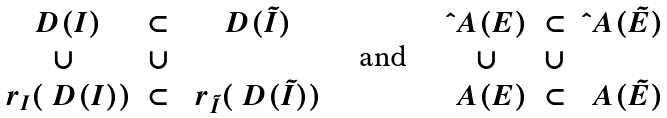Convert formula to latex. <formula><loc_0><loc_0><loc_500><loc_500>\begin{matrix} \ D ( I ) & \subset & \ D ( \tilde { I } ) \\ \cup & \cup \\ \ r _ { I } ( \ D ( I ) ) & \subset & \ r _ { \tilde { I } } ( \ D ( \tilde { I } ) ) \end{matrix} \ \quad \text {and} \ \quad \begin{matrix} \hat { \ } A ( E ) & \subset & \hat { \ } A ( \tilde { E } ) \\ \cup & \cup \\ \ A ( E ) & \subset & \ A ( \tilde { E } ) \end{matrix}</formula> 